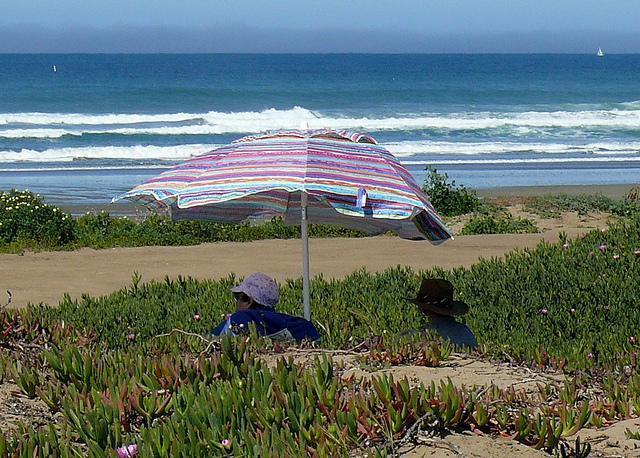How many people are sitting under the umbrella?
Give a very brief answer. 2. How many people are visible?
Give a very brief answer. 2. 